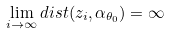Convert formula to latex. <formula><loc_0><loc_0><loc_500><loc_500>\lim _ { i \to \infty } d i s t ( z _ { i } , \alpha _ { \theta _ { 0 } } ) = \infty</formula> 